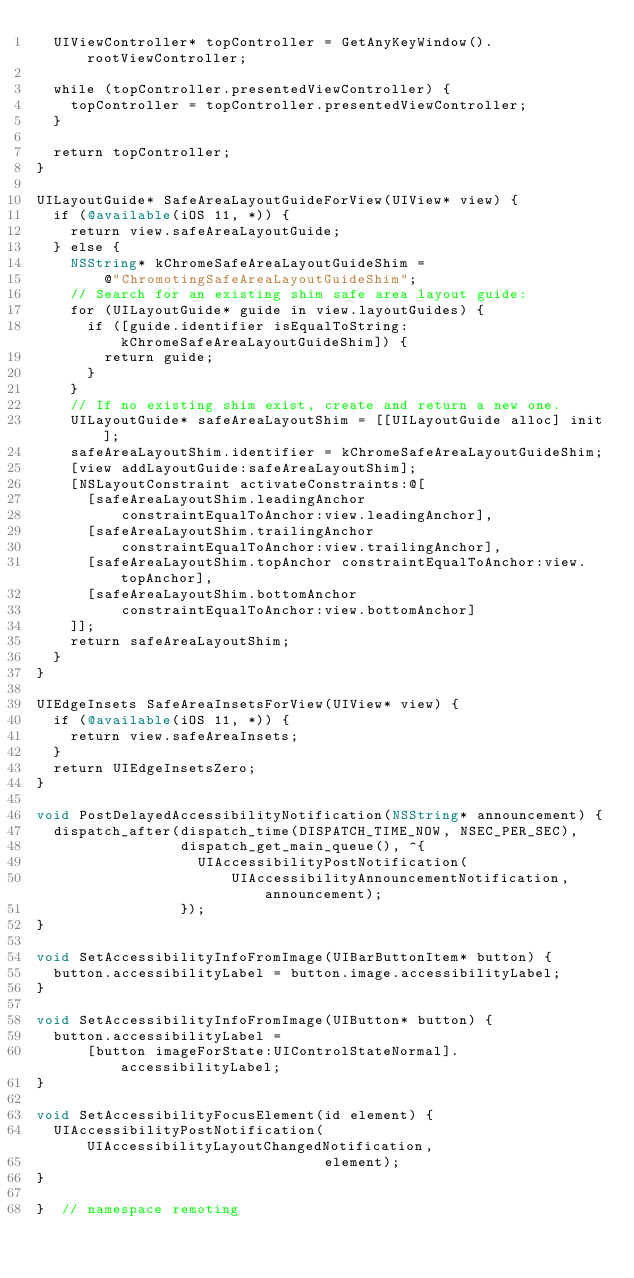Convert code to text. <code><loc_0><loc_0><loc_500><loc_500><_ObjectiveC_>  UIViewController* topController = GetAnyKeyWindow().rootViewController;

  while (topController.presentedViewController) {
    topController = topController.presentedViewController;
  }

  return topController;
}

UILayoutGuide* SafeAreaLayoutGuideForView(UIView* view) {
  if (@available(iOS 11, *)) {
    return view.safeAreaLayoutGuide;
  } else {
    NSString* kChromeSafeAreaLayoutGuideShim =
        @"ChromotingSafeAreaLayoutGuideShim";
    // Search for an existing shim safe area layout guide:
    for (UILayoutGuide* guide in view.layoutGuides) {
      if ([guide.identifier isEqualToString:kChromeSafeAreaLayoutGuideShim]) {
        return guide;
      }
    }
    // If no existing shim exist, create and return a new one.
    UILayoutGuide* safeAreaLayoutShim = [[UILayoutGuide alloc] init];
    safeAreaLayoutShim.identifier = kChromeSafeAreaLayoutGuideShim;
    [view addLayoutGuide:safeAreaLayoutShim];
    [NSLayoutConstraint activateConstraints:@[
      [safeAreaLayoutShim.leadingAnchor
          constraintEqualToAnchor:view.leadingAnchor],
      [safeAreaLayoutShim.trailingAnchor
          constraintEqualToAnchor:view.trailingAnchor],
      [safeAreaLayoutShim.topAnchor constraintEqualToAnchor:view.topAnchor],
      [safeAreaLayoutShim.bottomAnchor
          constraintEqualToAnchor:view.bottomAnchor]
    ]];
    return safeAreaLayoutShim;
  }
}

UIEdgeInsets SafeAreaInsetsForView(UIView* view) {
  if (@available(iOS 11, *)) {
    return view.safeAreaInsets;
  }
  return UIEdgeInsetsZero;
}

void PostDelayedAccessibilityNotification(NSString* announcement) {
  dispatch_after(dispatch_time(DISPATCH_TIME_NOW, NSEC_PER_SEC),
                 dispatch_get_main_queue(), ^{
                   UIAccessibilityPostNotification(
                       UIAccessibilityAnnouncementNotification, announcement);
                 });
}

void SetAccessibilityInfoFromImage(UIBarButtonItem* button) {
  button.accessibilityLabel = button.image.accessibilityLabel;
}

void SetAccessibilityInfoFromImage(UIButton* button) {
  button.accessibilityLabel =
      [button imageForState:UIControlStateNormal].accessibilityLabel;
}

void SetAccessibilityFocusElement(id element) {
  UIAccessibilityPostNotification(UIAccessibilityLayoutChangedNotification,
                                  element);
}

}  // namespace remoting
</code> 